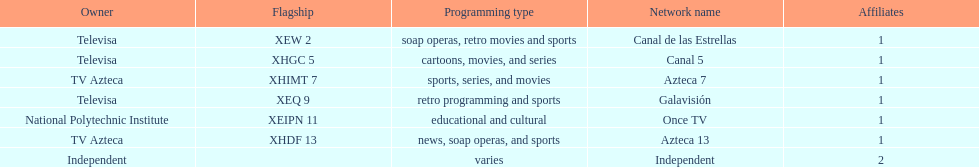What is the number of networks that are owned by televisa? 3. 